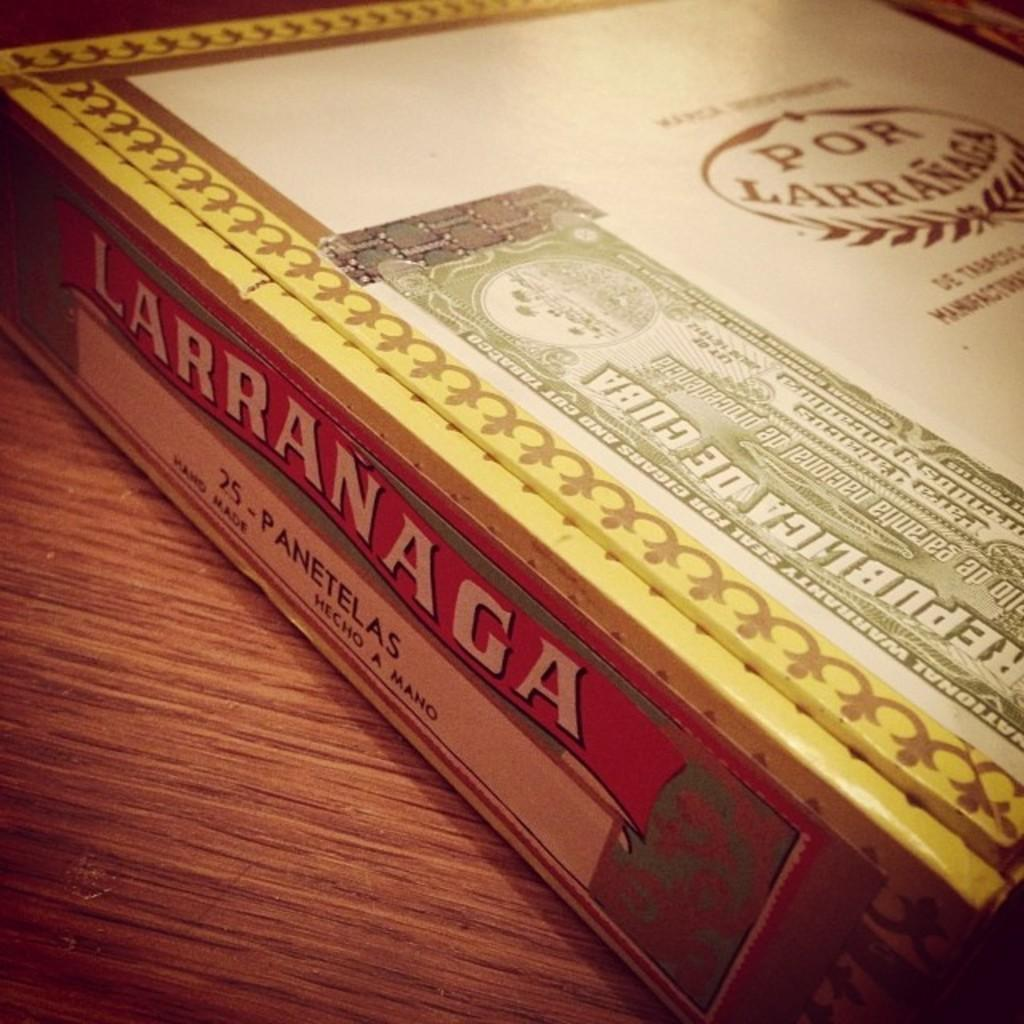<image>
Write a terse but informative summary of the picture. A large box of Larranaga cigars sits on a table 